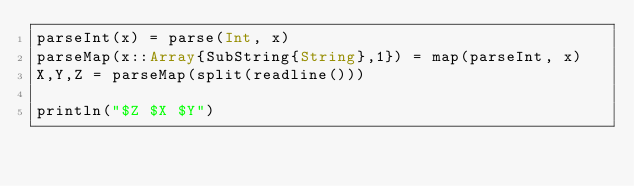Convert code to text. <code><loc_0><loc_0><loc_500><loc_500><_Julia_>parseInt(x) = parse(Int, x)
parseMap(x::Array{SubString{String},1}) = map(parseInt, x)
X,Y,Z = parseMap(split(readline()))
 
println("$Z $X $Y")</code> 